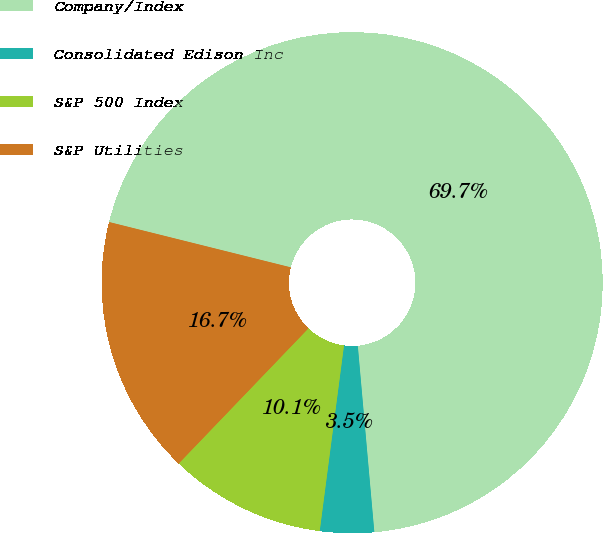Convert chart. <chart><loc_0><loc_0><loc_500><loc_500><pie_chart><fcel>Company/Index<fcel>Consolidated Edison Inc<fcel>S&P 500 Index<fcel>S&P Utilities<nl><fcel>69.7%<fcel>3.48%<fcel>10.1%<fcel>16.72%<nl></chart> 